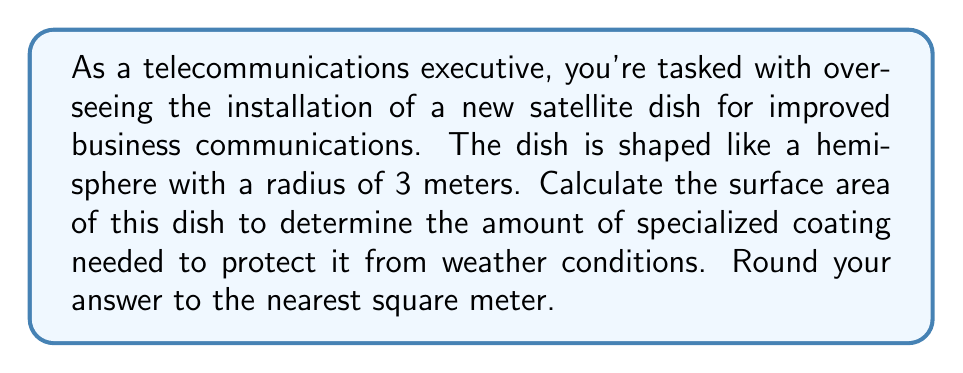Help me with this question. Let's approach this step-by-step:

1) The dish is shaped like a hemisphere, which is half of a sphere.

2) The formula for the surface area of a sphere is:
   $$A = 4\pi r^2$$

3) However, we only need half of this for a hemisphere, plus the area of the circular base:
   $$A_{hemisphere} = 2\pi r^2 + \pi r^2 = 3\pi r^2$$

4) We're given that the radius $r = 3$ meters.

5) Let's substitute this into our formula:
   $$A = 3\pi (3)^2 = 3\pi (9) = 27\pi$$

6) Calculate this value:
   $$27\pi \approx 84.82 \text{ m}^2$$

7) Rounding to the nearest square meter:
   $$84.82 \text{ m}^2 \approx 85 \text{ m}^2$$

[asy]
import geometry;

size(200);
draw(circle((0,0),3));
draw((-3,0)--(3,0));
fill((-3,0)--arc((0,0),3,0,180)--(3,0)--cycle,lightgray);
label("3m",(-1.5,1.5),N);
[/asy]
Answer: 85 m² 